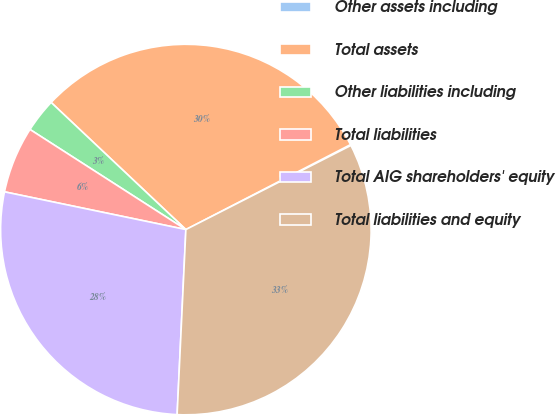Convert chart to OTSL. <chart><loc_0><loc_0><loc_500><loc_500><pie_chart><fcel>Other assets including<fcel>Total assets<fcel>Other liabilities including<fcel>Total liabilities<fcel>Total AIG shareholders' equity<fcel>Total liabilities and equity<nl><fcel>0.08%<fcel>30.38%<fcel>2.95%<fcel>5.82%<fcel>27.51%<fcel>33.25%<nl></chart> 